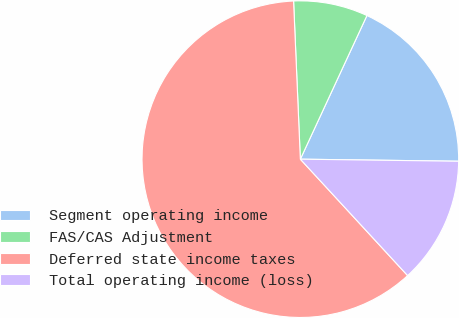Convert chart. <chart><loc_0><loc_0><loc_500><loc_500><pie_chart><fcel>Segment operating income<fcel>FAS/CAS Adjustment<fcel>Deferred state income taxes<fcel>Total operating income (loss)<nl><fcel>18.3%<fcel>7.59%<fcel>61.17%<fcel>12.94%<nl></chart> 